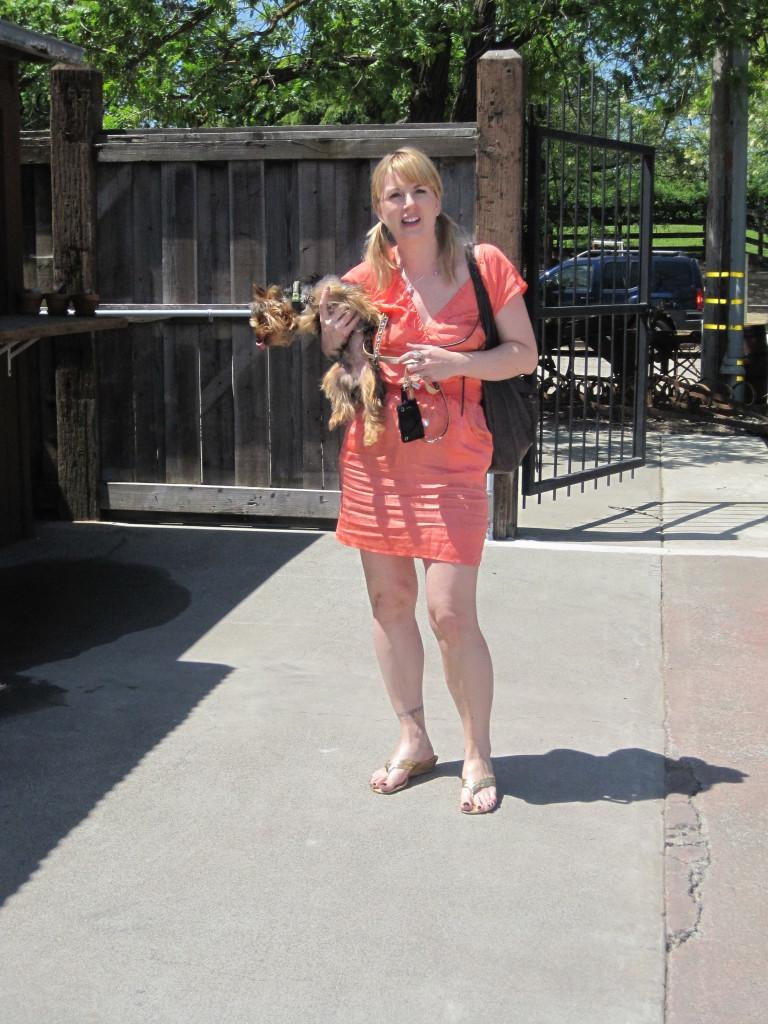Who is in the image? There is a woman in the image. What is the woman doing in the image? The woman is standing and holding a dog. What can be seen in the background of the image? There are vehicles, trees, and a gate visible in the background. What color is the orange that the woman is attempting to base in the image? There is no orange present in the image, nor is there any mention of an attempt to base something. 